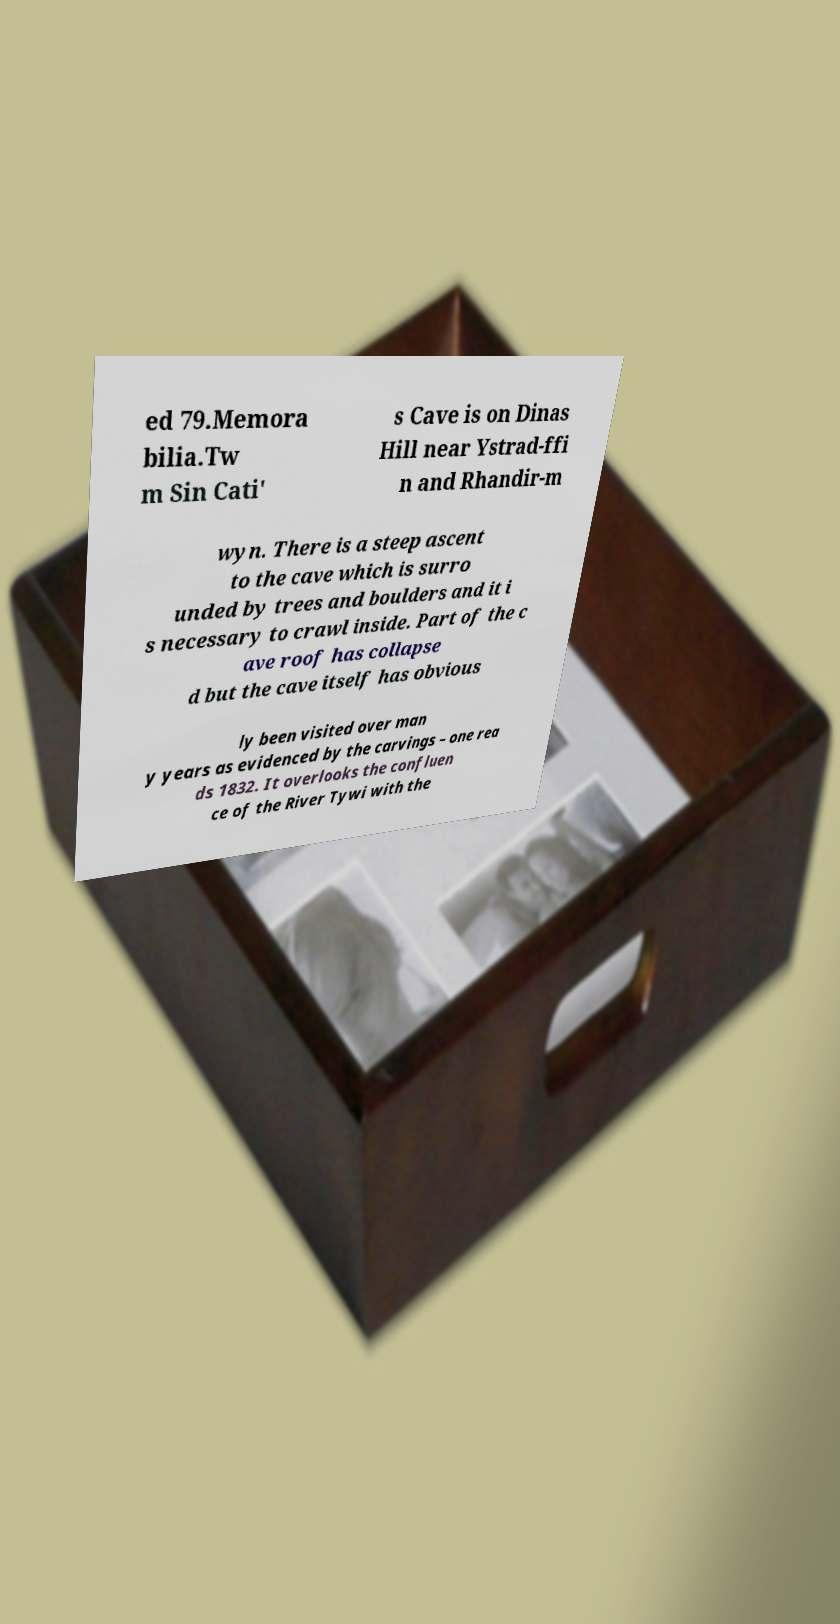I need the written content from this picture converted into text. Can you do that? ed 79.Memora bilia.Tw m Sin Cati' s Cave is on Dinas Hill near Ystrad-ffi n and Rhandir-m wyn. There is a steep ascent to the cave which is surro unded by trees and boulders and it i s necessary to crawl inside. Part of the c ave roof has collapse d but the cave itself has obvious ly been visited over man y years as evidenced by the carvings – one rea ds 1832. It overlooks the confluen ce of the River Tywi with the 